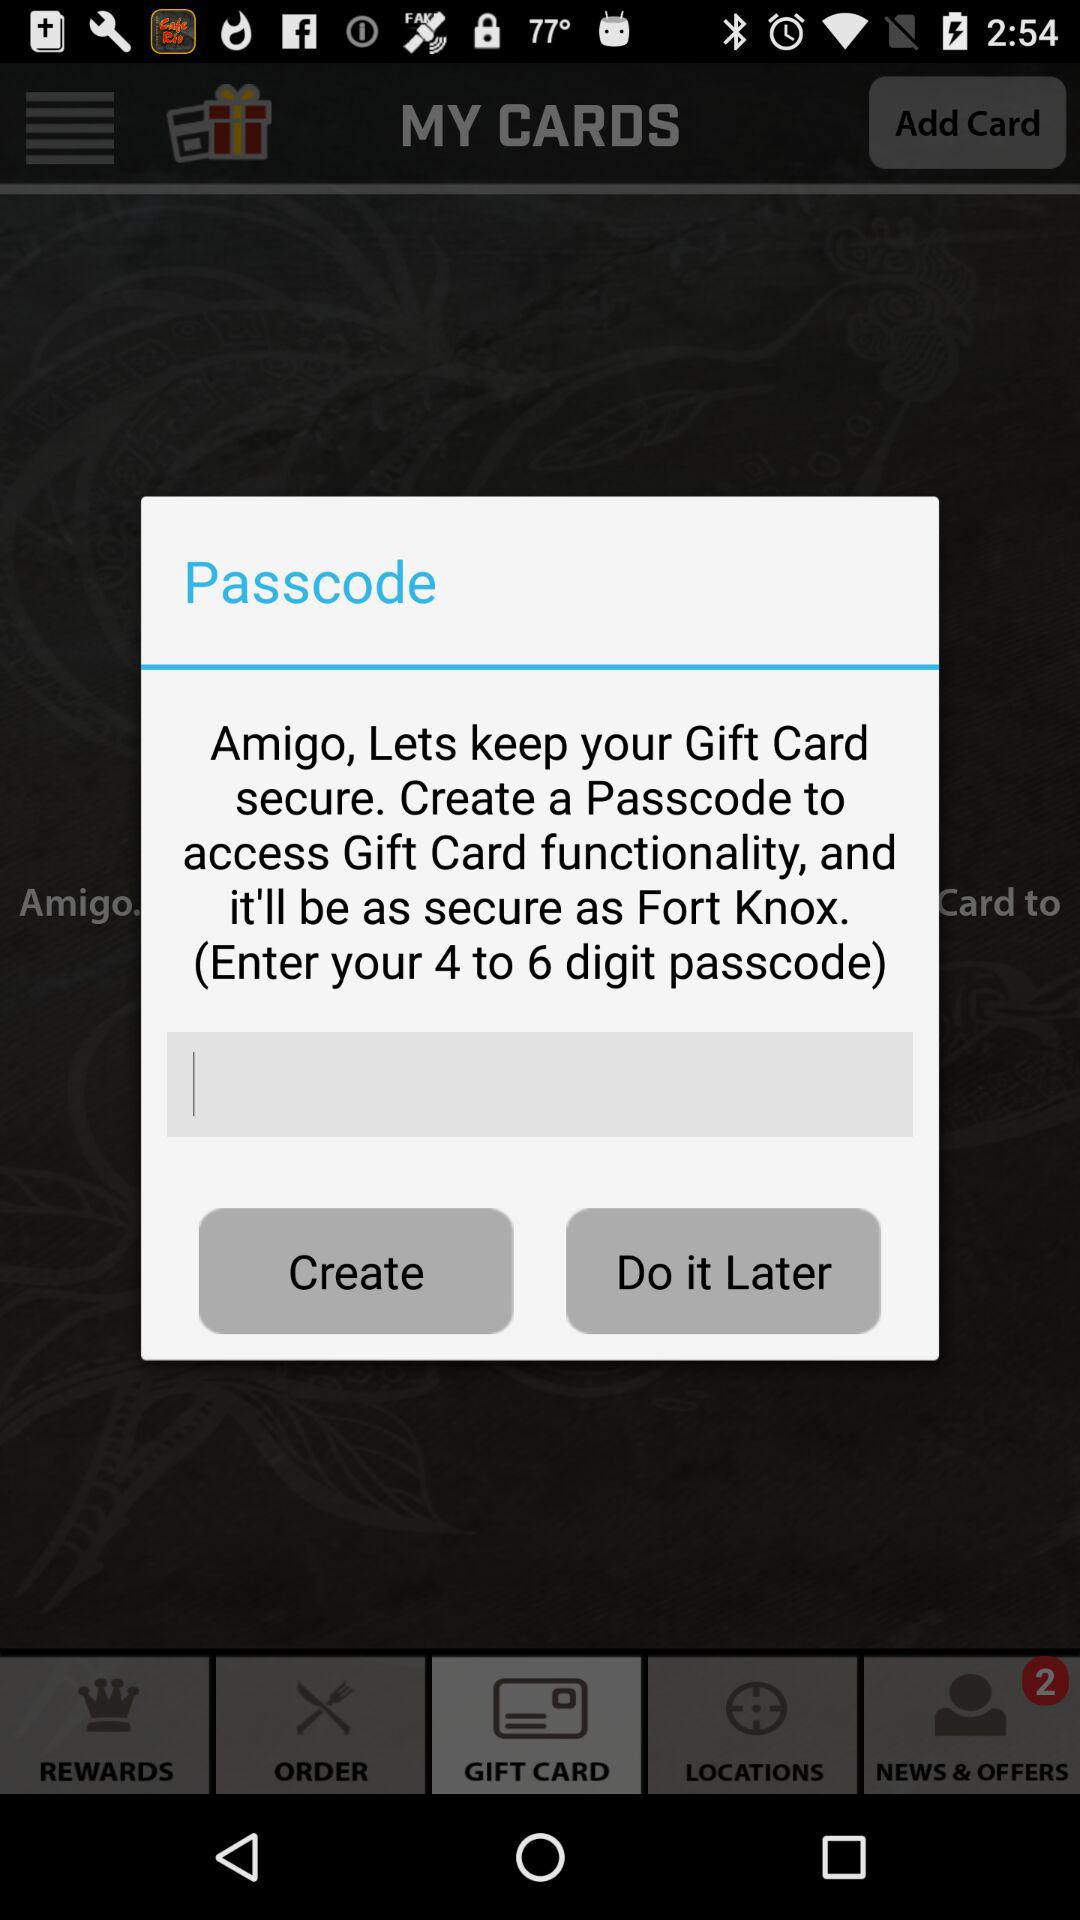How many digits does the passcode need to be?
Answer the question using a single word or phrase. 4 to 6 